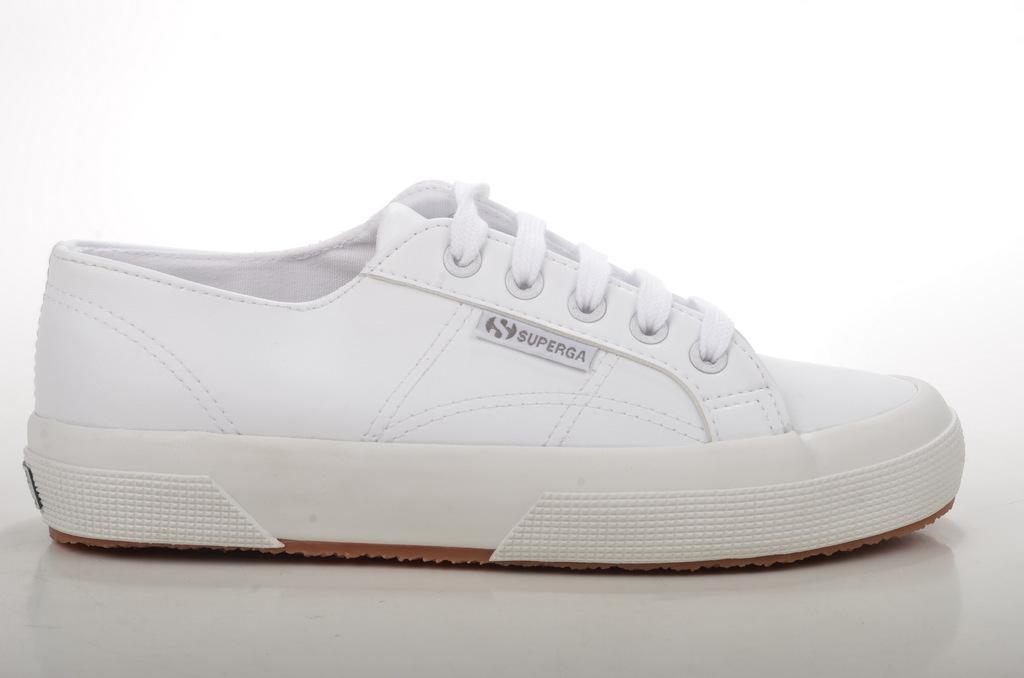In one or two sentences, can you explain what this image depicts? In this image I can see a shoe which is white and brown in color on the white colored surface and I can see the white colored background. 